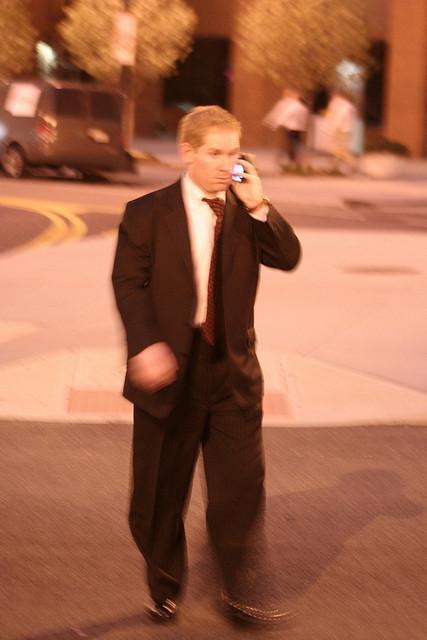What is this man doing?
Keep it brief. Talking on cell phone. Which hand holds the phone?
Give a very brief answer. Left. Does the man have facial hair?
Write a very short answer. No. Is the man's tie straight?
Answer briefly. No. 